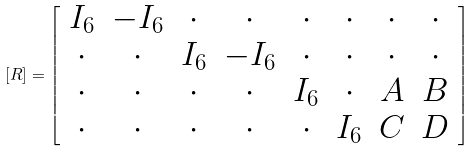Convert formula to latex. <formula><loc_0><loc_0><loc_500><loc_500>[ R ] = \left [ \begin{array} { c c c c c c c c } I _ { 6 } & - I _ { 6 } & \cdot & \cdot & \cdot & \cdot & \cdot & \cdot \\ \cdot & \cdot & I _ { 6 } & - I _ { 6 } & \cdot & \cdot & \cdot & \cdot \\ \cdot & \cdot & \cdot & \cdot & I _ { 6 } & \cdot & A & B \\ \cdot & \cdot & \cdot & \cdot & \cdot & I _ { 6 } & C & D \end{array} \right ]</formula> 